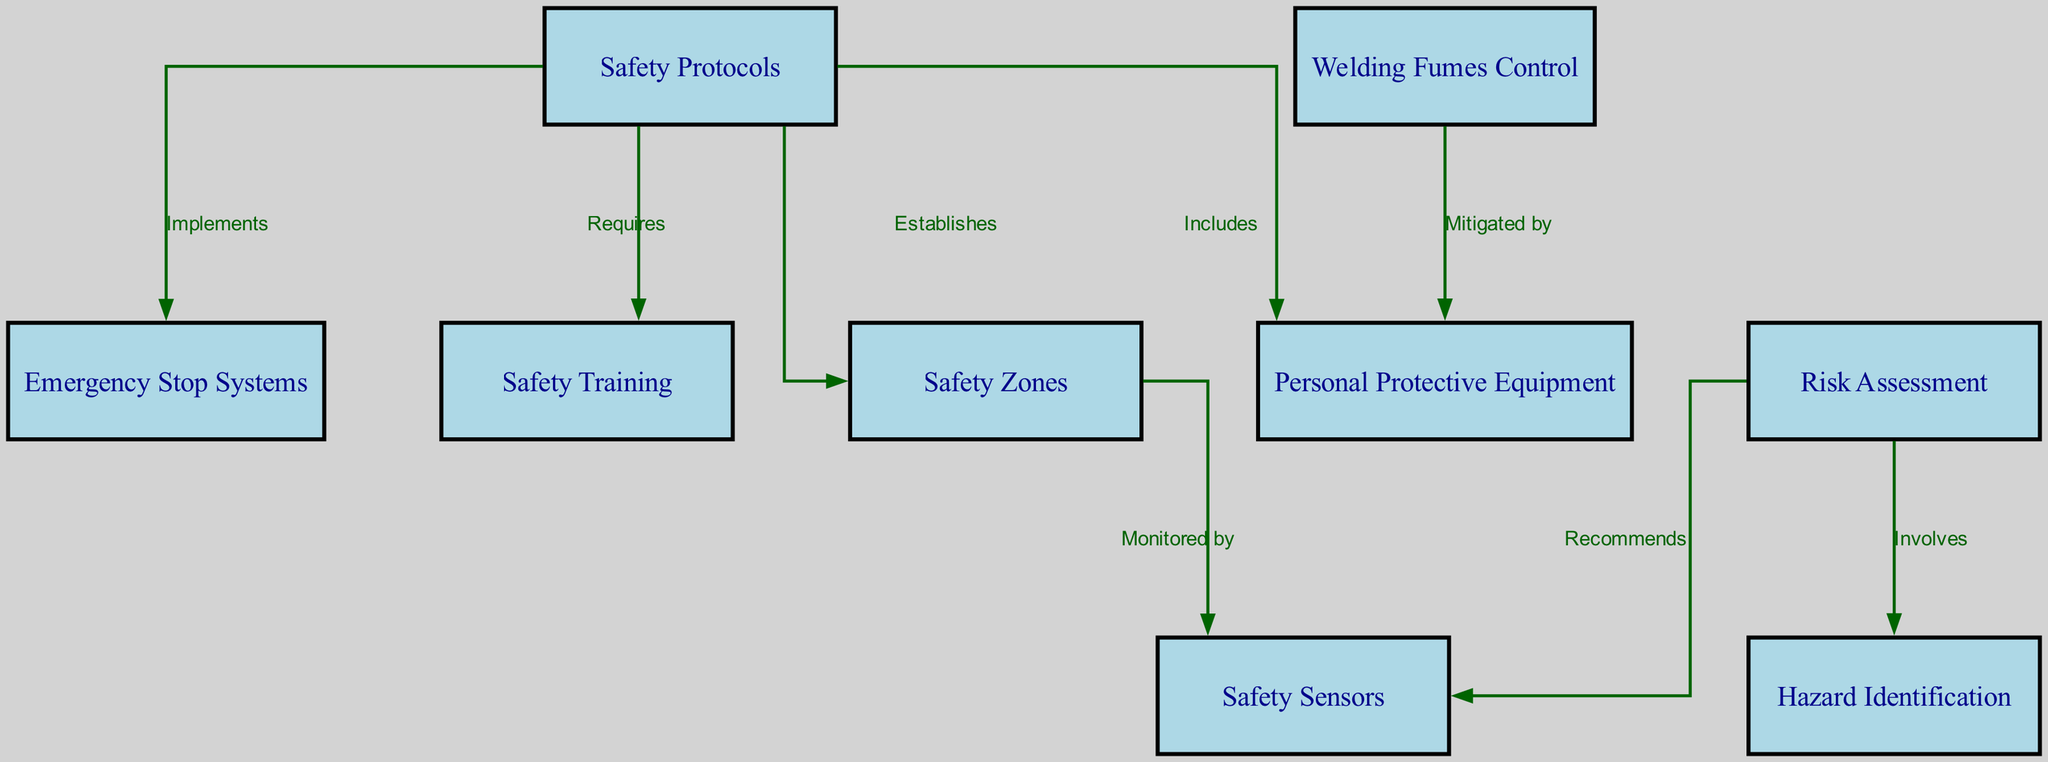What are the two main categories represented in the diagram? The diagram includes nodes specifically titled "Safety Protocols" and "Risk Assessment." These serve as the primary categories within the concept map.
Answer: Safety Protocols, Risk Assessment How many nodes are depicted in the diagram? The diagram contains a total of 9 nodes as listed: Safety Protocols, Risk Assessment, Personal Protective Equipment, Safety Sensors, Emergency Stop Systems, Safety Training, Hazard Identification, Safety Zones, and Welding Fumes Control.
Answer: 9 What relationship connects safety protocols with personal protective equipment? In the diagram, the relationship labeled "Includes" indicates that safety protocols include personal protective equipment as part of their measures.
Answer: Includes Which node is monitored by safety zones? According to the diagram, "Safety Sensors" is the node that is monitored by the "Safety Zones." This information is conveyed through the edge labeled "Monitored by."
Answer: Safety Sensors What is recommended during the risk assessment process? The risk assessment process recommends the use of "Safety Sensors," which is illustrated in the diagram with the label "Recommends" connecting risk assessment to safety sensors.
Answer: Safety Sensors How does the diagram illustrate the mitigation of welding fumes? The diagram demonstrates that welding fumes are mitigated by personal protective equipment, shown through the relationship labeled "Mitigated by."
Answer: Mitigated by What is established by safety protocols? Safety protocols establish "Safety Zones," as depicted in the diagram with an edge connecting these two nodes and labeled "Establishes."
Answer: Safety Zones Which component requires safety training? The diagram shows that "Safety Protocols" requires "Safety Training," indicated by the edge labeled "Requires," indicating that safety training is essential for implementing safety protocols.
Answer: Safety Training What is one of the key elements involved in risk assessment? The diagram identifies "Hazard Identification" as a key element involved in risk assessment, connected by the labeled edge "Involves."
Answer: Hazard Identification 